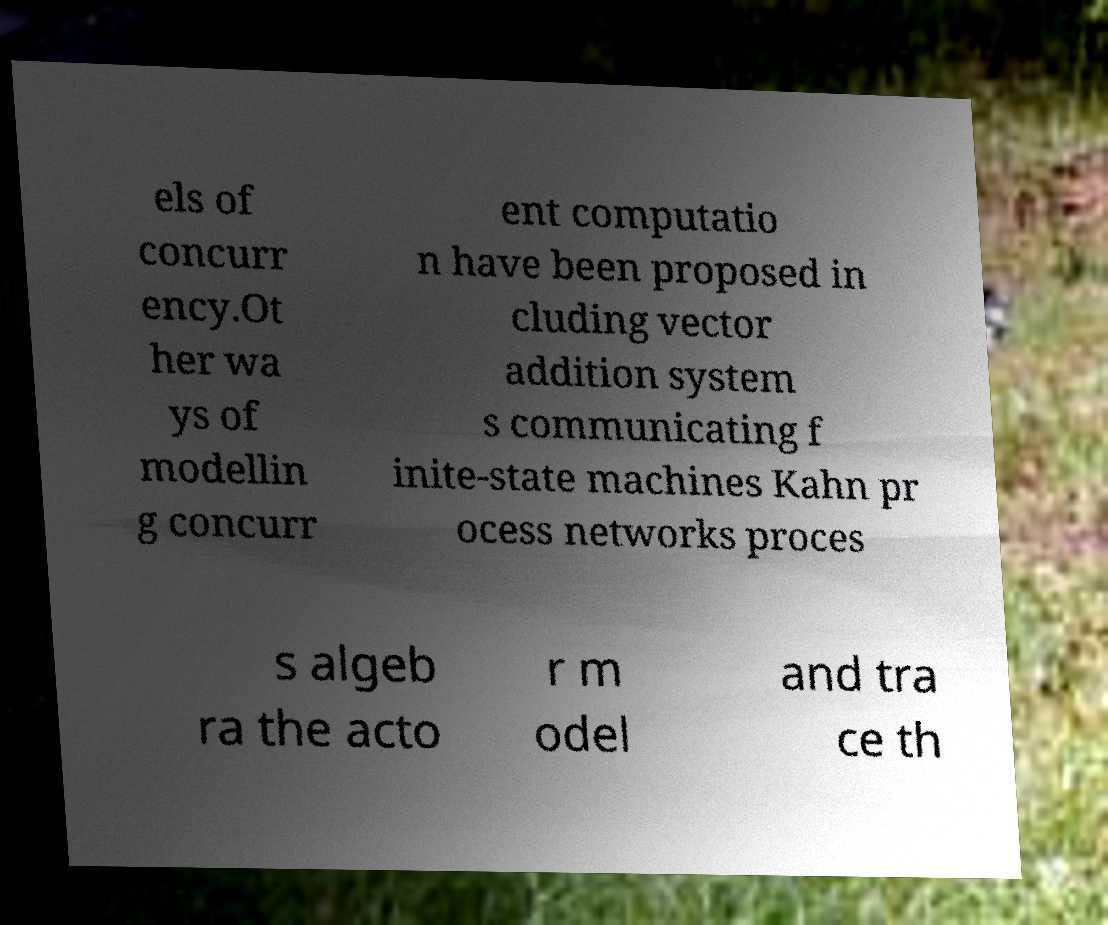Please identify and transcribe the text found in this image. els of concurr ency.Ot her wa ys of modellin g concurr ent computatio n have been proposed in cluding vector addition system s communicating f inite-state machines Kahn pr ocess networks proces s algeb ra the acto r m odel and tra ce th 